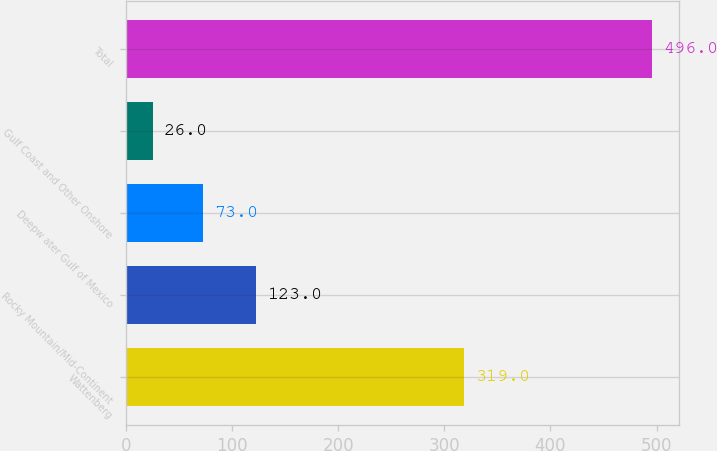<chart> <loc_0><loc_0><loc_500><loc_500><bar_chart><fcel>Wattenberg<fcel>Rocky Mountain/Mid-Continent<fcel>Deepw ater Gulf of Mexico<fcel>Gulf Coast and Other Onshore<fcel>Total<nl><fcel>319<fcel>123<fcel>73<fcel>26<fcel>496<nl></chart> 